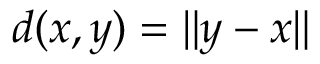<formula> <loc_0><loc_0><loc_500><loc_500>d ( x , y ) = \| y - x \|</formula> 